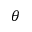Convert formula to latex. <formula><loc_0><loc_0><loc_500><loc_500>\theta</formula> 